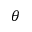Convert formula to latex. <formula><loc_0><loc_0><loc_500><loc_500>\theta</formula> 